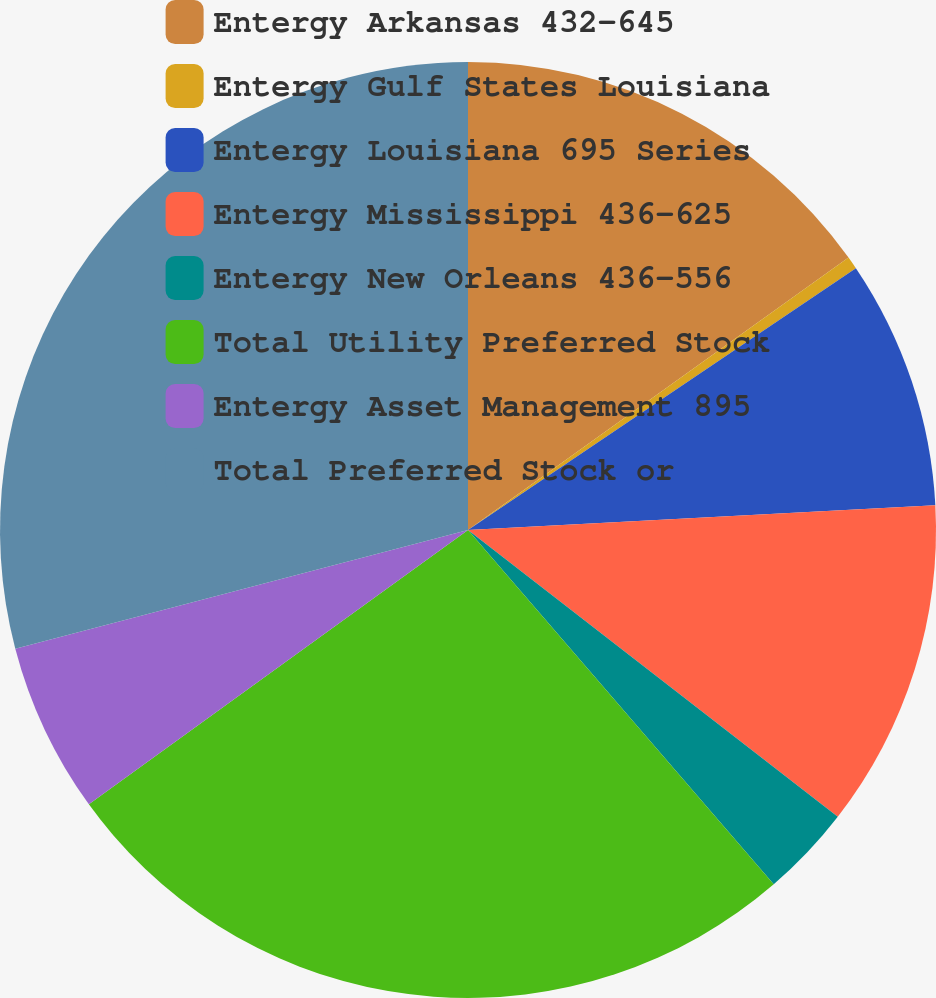Convert chart. <chart><loc_0><loc_0><loc_500><loc_500><pie_chart><fcel>Entergy Arkansas 432-645<fcel>Entergy Gulf States Louisiana<fcel>Entergy Louisiana 695 Series<fcel>Entergy Mississippi 436-625<fcel>Entergy New Orleans 436-556<fcel>Total Utility Preferred Stock<fcel>Entergy Asset Management 895<fcel>Total Preferred Stock or<nl><fcel>15.11%<fcel>0.44%<fcel>8.61%<fcel>11.34%<fcel>3.17%<fcel>26.36%<fcel>5.89%<fcel>29.08%<nl></chart> 